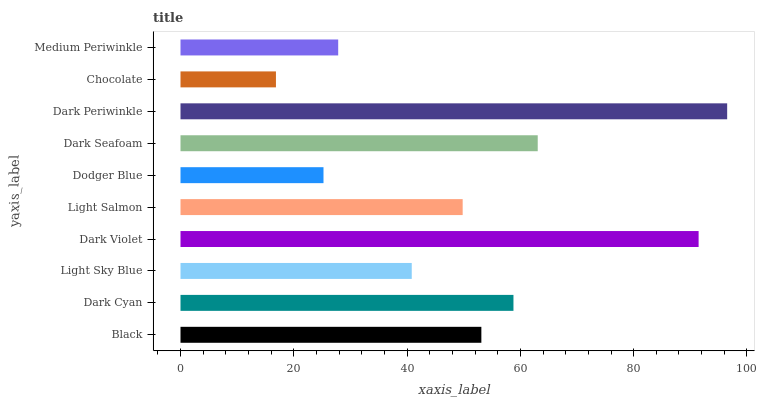Is Chocolate the minimum?
Answer yes or no. Yes. Is Dark Periwinkle the maximum?
Answer yes or no. Yes. Is Dark Cyan the minimum?
Answer yes or no. No. Is Dark Cyan the maximum?
Answer yes or no. No. Is Dark Cyan greater than Black?
Answer yes or no. Yes. Is Black less than Dark Cyan?
Answer yes or no. Yes. Is Black greater than Dark Cyan?
Answer yes or no. No. Is Dark Cyan less than Black?
Answer yes or no. No. Is Black the high median?
Answer yes or no. Yes. Is Light Salmon the low median?
Answer yes or no. Yes. Is Medium Periwinkle the high median?
Answer yes or no. No. Is Dark Seafoam the low median?
Answer yes or no. No. 